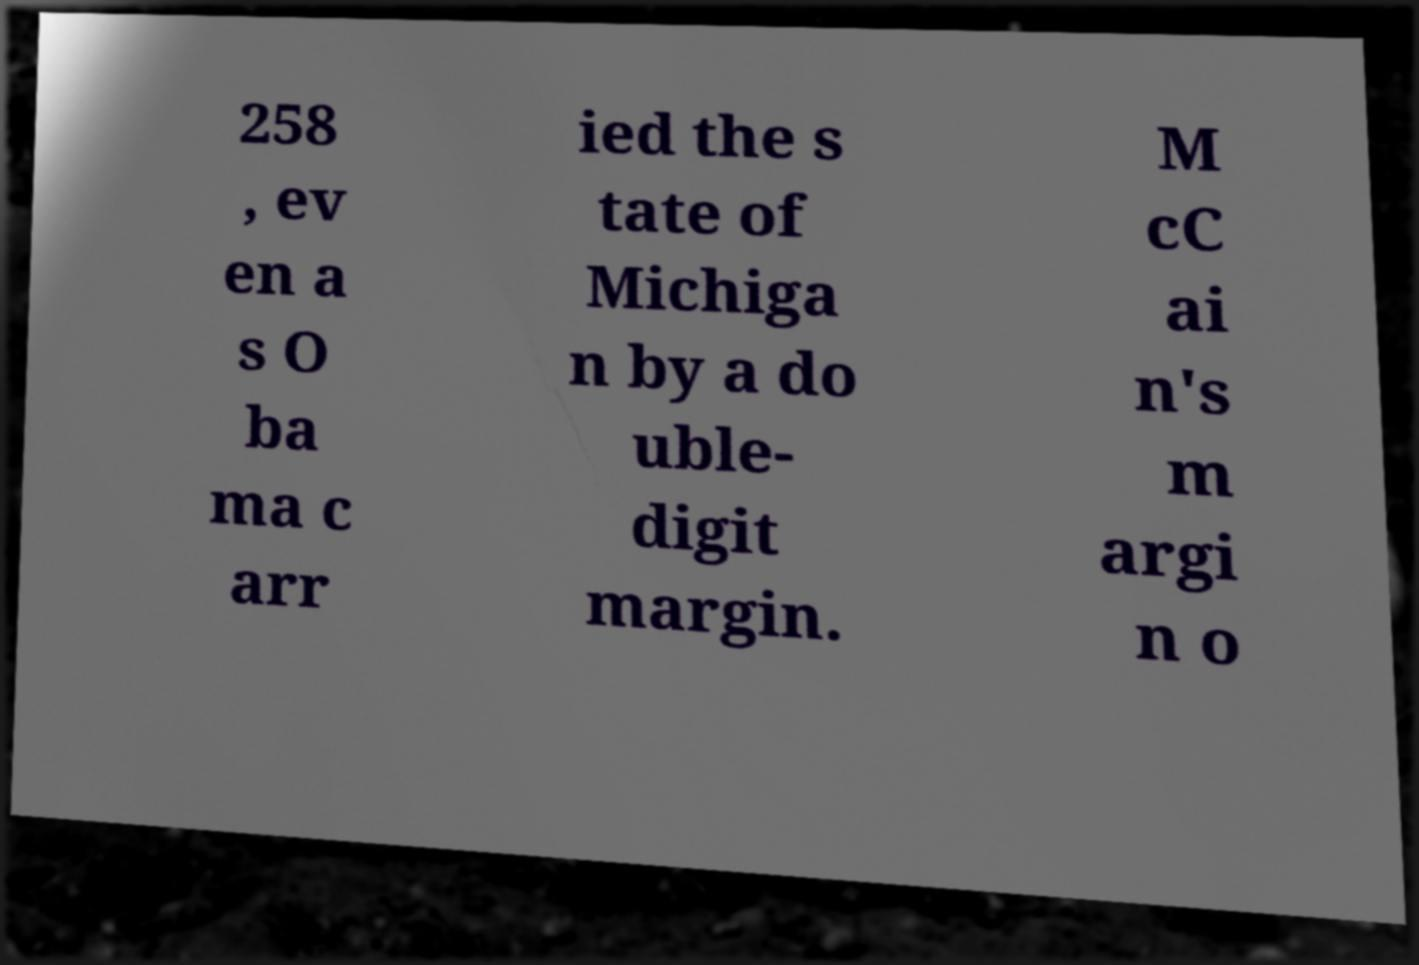Could you assist in decoding the text presented in this image and type it out clearly? 258 , ev en a s O ba ma c arr ied the s tate of Michiga n by a do uble- digit margin. M cC ai n's m argi n o 